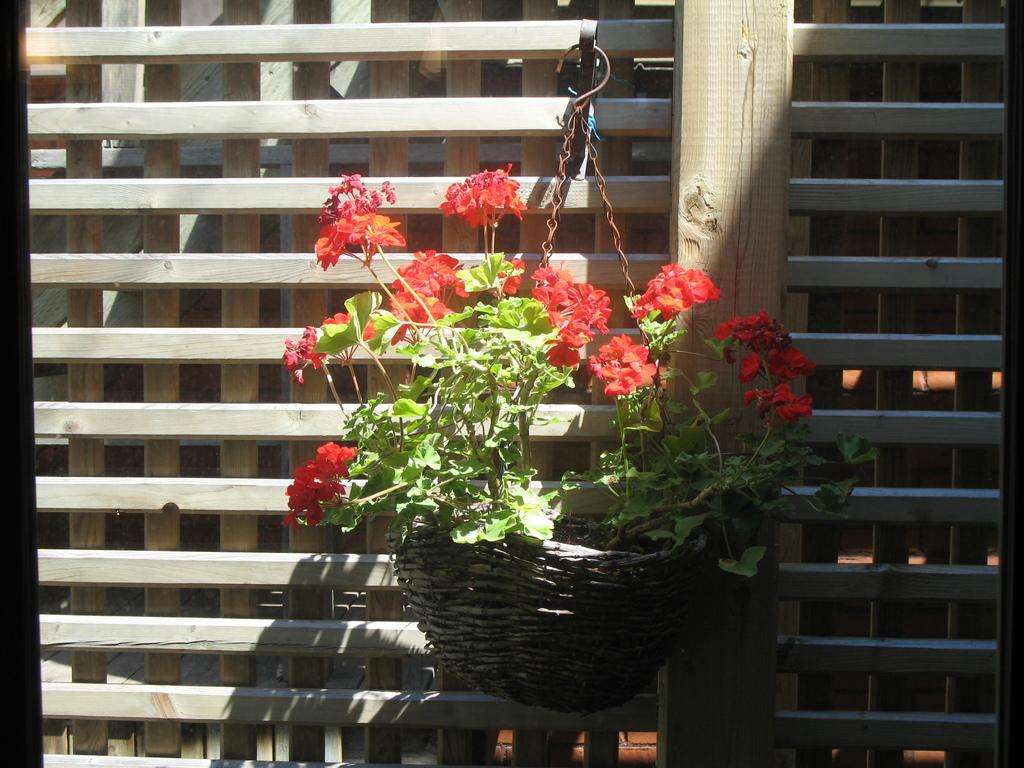What type of wall is shown in the image? There is a wooden plank wall in the image. What is attached to the wall? There is a hanger on the wall. What is hanging from the hanger? Plants are hanging from the hanger. What is associated with the plants? There is a bowl associated with the plants. What color are the flowers on the plants? The plants have red flowers. What type of industry is depicted in the image? There is no industry depicted in the image; it features a wooden plank wall with a hanger and plants. Can you hear the voice of the person who hung the plants in the image? There is no person or voice present in the image; it only shows a wooden plank wall with a hanger and plants. 